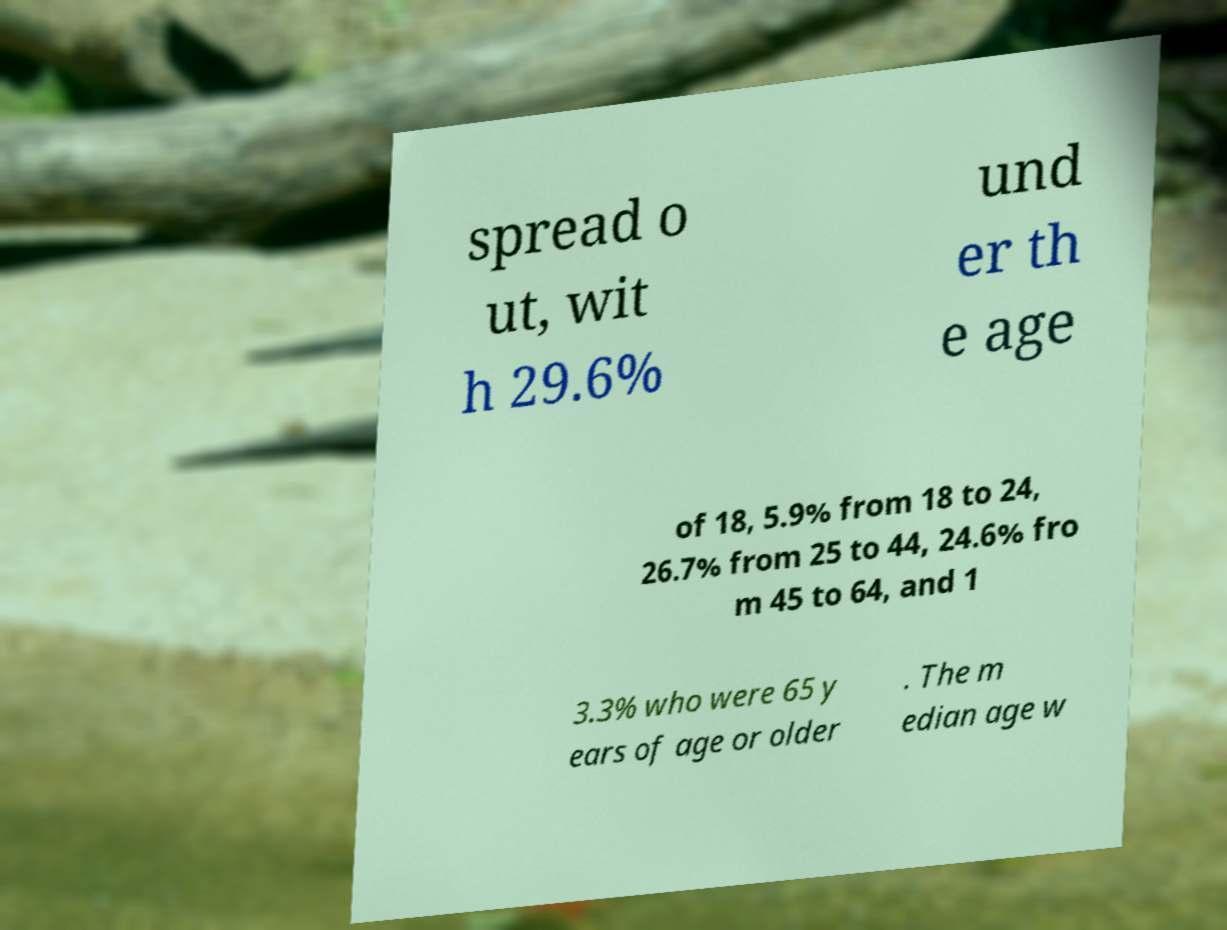Can you read and provide the text displayed in the image?This photo seems to have some interesting text. Can you extract and type it out for me? spread o ut, wit h 29.6% und er th e age of 18, 5.9% from 18 to 24, 26.7% from 25 to 44, 24.6% fro m 45 to 64, and 1 3.3% who were 65 y ears of age or older . The m edian age w 